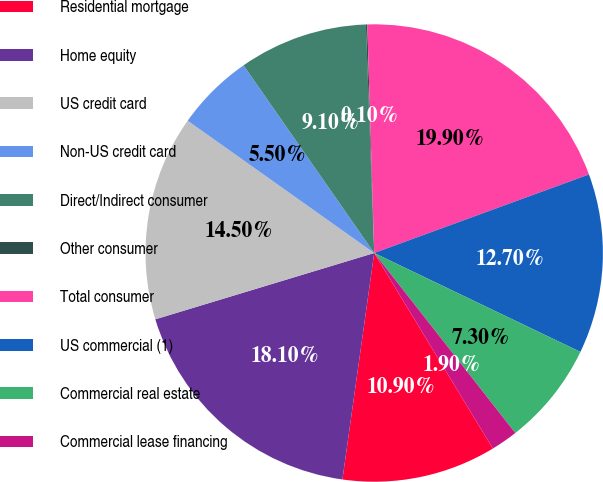Convert chart to OTSL. <chart><loc_0><loc_0><loc_500><loc_500><pie_chart><fcel>Residential mortgage<fcel>Home equity<fcel>US credit card<fcel>Non-US credit card<fcel>Direct/Indirect consumer<fcel>Other consumer<fcel>Total consumer<fcel>US commercial (1)<fcel>Commercial real estate<fcel>Commercial lease financing<nl><fcel>10.9%<fcel>18.1%<fcel>14.5%<fcel>5.5%<fcel>9.1%<fcel>0.1%<fcel>19.9%<fcel>12.7%<fcel>7.3%<fcel>1.9%<nl></chart> 